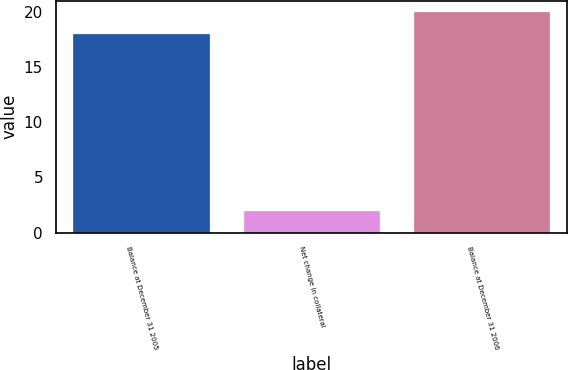<chart> <loc_0><loc_0><loc_500><loc_500><bar_chart><fcel>Balance at December 31 2005<fcel>Net change in collateral<fcel>Balance at December 31 2006<nl><fcel>18<fcel>2<fcel>20<nl></chart> 